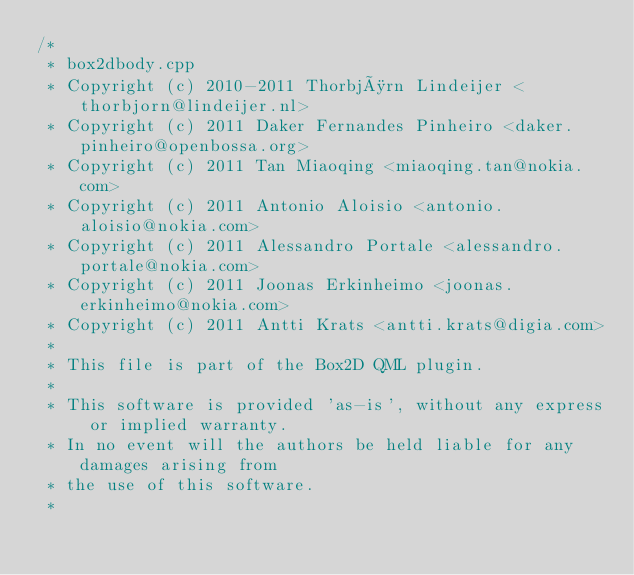Convert code to text. <code><loc_0><loc_0><loc_500><loc_500><_C++_>/*
 * box2dbody.cpp
 * Copyright (c) 2010-2011 Thorbjørn Lindeijer <thorbjorn@lindeijer.nl>
 * Copyright (c) 2011 Daker Fernandes Pinheiro <daker.pinheiro@openbossa.org>
 * Copyright (c) 2011 Tan Miaoqing <miaoqing.tan@nokia.com>
 * Copyright (c) 2011 Antonio Aloisio <antonio.aloisio@nokia.com>
 * Copyright (c) 2011 Alessandro Portale <alessandro.portale@nokia.com>
 * Copyright (c) 2011 Joonas Erkinheimo <joonas.erkinheimo@nokia.com>
 * Copyright (c) 2011 Antti Krats <antti.krats@digia.com>
 *
 * This file is part of the Box2D QML plugin.
 *
 * This software is provided 'as-is', without any express or implied warranty.
 * In no event will the authors be held liable for any damages arising from
 * the use of this software.
 *</code> 